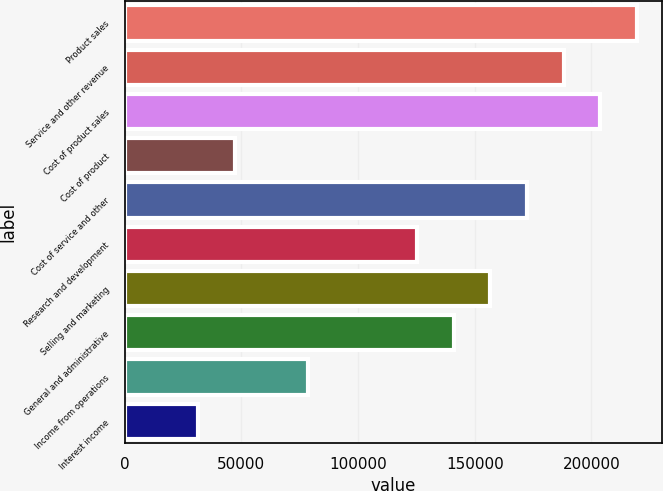Convert chart. <chart><loc_0><loc_0><loc_500><loc_500><bar_chart><fcel>Product sales<fcel>Service and other revenue<fcel>Cost of product sales<fcel>Cost of product<fcel>Cost of service and other<fcel>Research and development<fcel>Selling and marketing<fcel>General and administrative<fcel>Income from operations<fcel>Interest income<nl><fcel>219357<fcel>188046<fcel>203701<fcel>47143.4<fcel>172390<fcel>125422<fcel>156734<fcel>141078<fcel>78455<fcel>31487.6<nl></chart> 